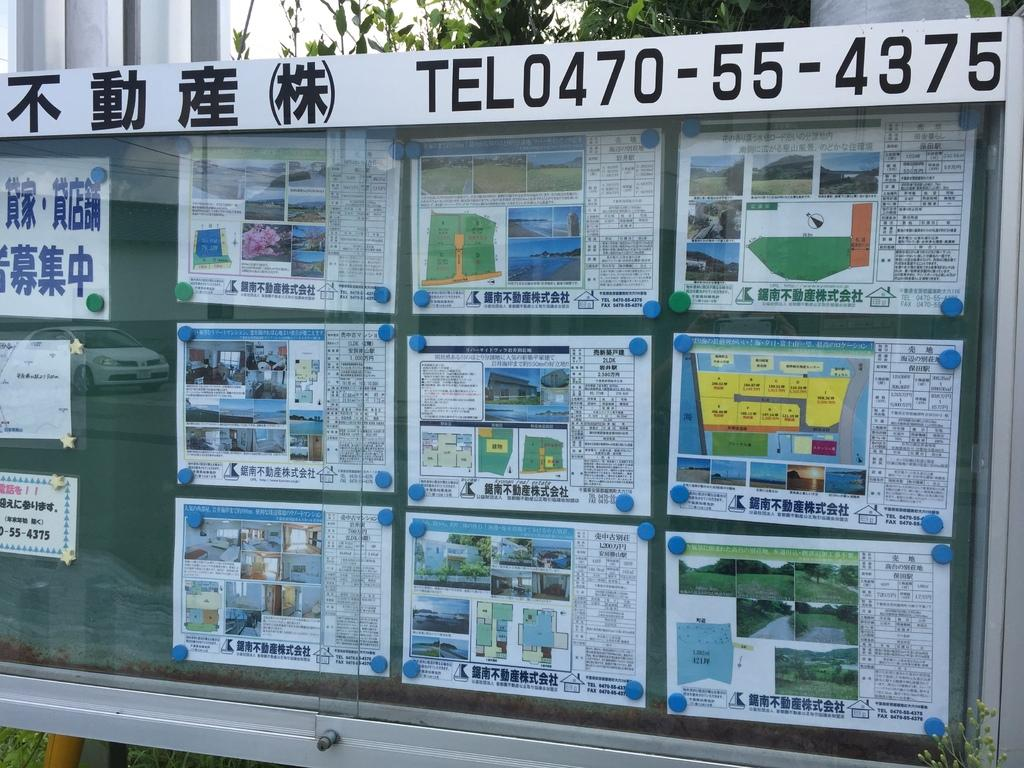<image>
Offer a succinct explanation of the picture presented. A telephone number is listed above a case with printed pages in it. 